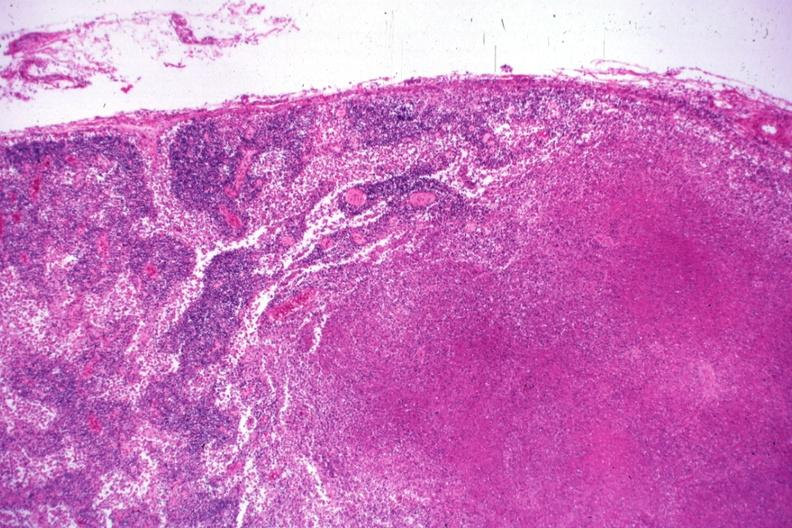what does this image show?
Answer the question using a single word or phrase. Low typical necrotizing lesion 